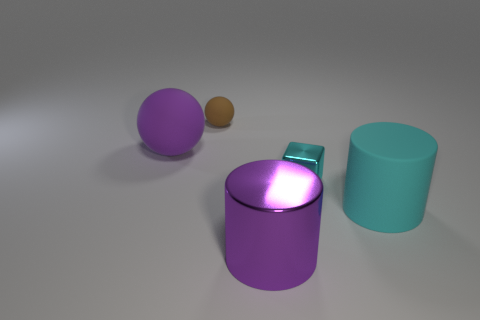How many cylinders are tiny brown objects or gray things?
Provide a succinct answer. 0. How many purple matte things are there?
Your response must be concise. 1. Does the cyan rubber thing have the same shape as the large purple thing that is right of the small brown matte object?
Offer a terse response. Yes. What is the size of the metallic block that is the same color as the large matte cylinder?
Offer a very short reply. Small. What number of things are either tiny cyan blocks or small brown matte balls?
Provide a succinct answer. 2. There is a thing behind the big matte object behind the big rubber cylinder; what shape is it?
Make the answer very short. Sphere. There is a metallic object that is in front of the big cyan matte thing; is it the same shape as the large cyan object?
Make the answer very short. Yes. What is the size of the brown ball that is the same material as the big cyan object?
Give a very brief answer. Small. How many things are either small metal things on the right side of the big purple matte sphere or rubber balls right of the big purple ball?
Provide a short and direct response. 2. Is the number of large cyan matte things that are behind the tiny brown matte sphere the same as the number of tiny cyan shiny things that are in front of the cyan metal cube?
Your answer should be compact. Yes. 